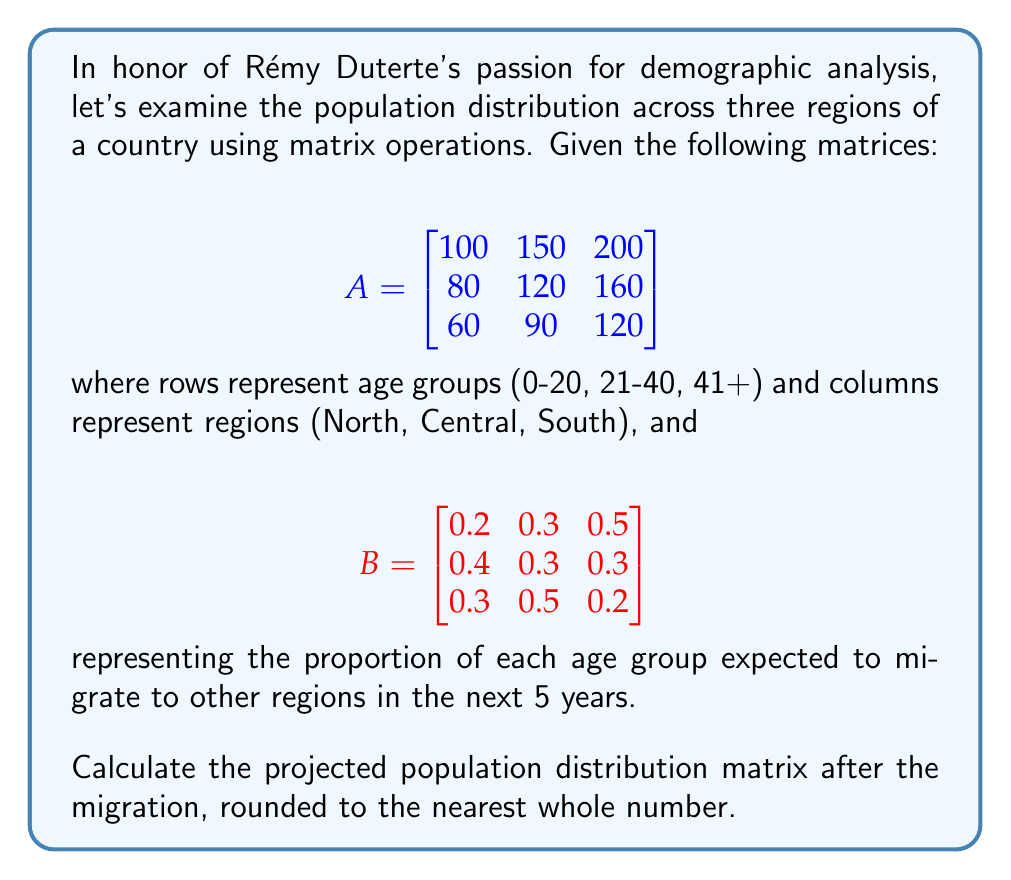What is the answer to this math problem? To solve this problem, we need to multiply matrix A by matrix B. This operation will give us the new population distribution after migration.

Step 1: Multiply A and B
$$C = A \times B$$

Step 2: Perform the matrix multiplication
$$(c_{ij}) = \sum_{k=1}^{3} a_{ik} \cdot b_{kj}$$

For example, $c_{11} = (100 \cdot 0.2) + (150 \cdot 0.4) + (200 \cdot 0.3) = 20 + 60 + 60 = 140$

Calculating all elements:

$$C = \begin{bmatrix}
140 & 155 & 155 \\
112 & 124 & 124 \\
84 & 93 & 93
\end{bmatrix}$$

Step 3: Round the results to the nearest whole number (already done in this case)

The final projected population distribution matrix after migration is:

$$C = \begin{bmatrix}
140 & 155 & 155 \\
112 & 124 & 124 \\
84 & 93 & 93
\end{bmatrix}$$
Answer: $$\begin{bmatrix}
140 & 155 & 155 \\
112 & 124 & 124 \\
84 & 93 & 93
\end{bmatrix}$$ 